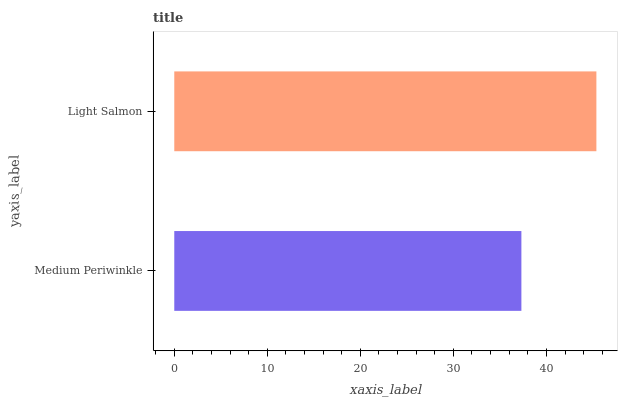Is Medium Periwinkle the minimum?
Answer yes or no. Yes. Is Light Salmon the maximum?
Answer yes or no. Yes. Is Light Salmon the minimum?
Answer yes or no. No. Is Light Salmon greater than Medium Periwinkle?
Answer yes or no. Yes. Is Medium Periwinkle less than Light Salmon?
Answer yes or no. Yes. Is Medium Periwinkle greater than Light Salmon?
Answer yes or no. No. Is Light Salmon less than Medium Periwinkle?
Answer yes or no. No. Is Light Salmon the high median?
Answer yes or no. Yes. Is Medium Periwinkle the low median?
Answer yes or no. Yes. Is Medium Periwinkle the high median?
Answer yes or no. No. Is Light Salmon the low median?
Answer yes or no. No. 